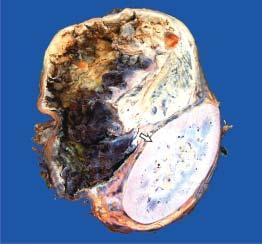what shows cystic change while solid areas show dark brown, necrotic and haemorrhagic tumour?
Answer the question using a single word or phrase. Cut surface of tumour 